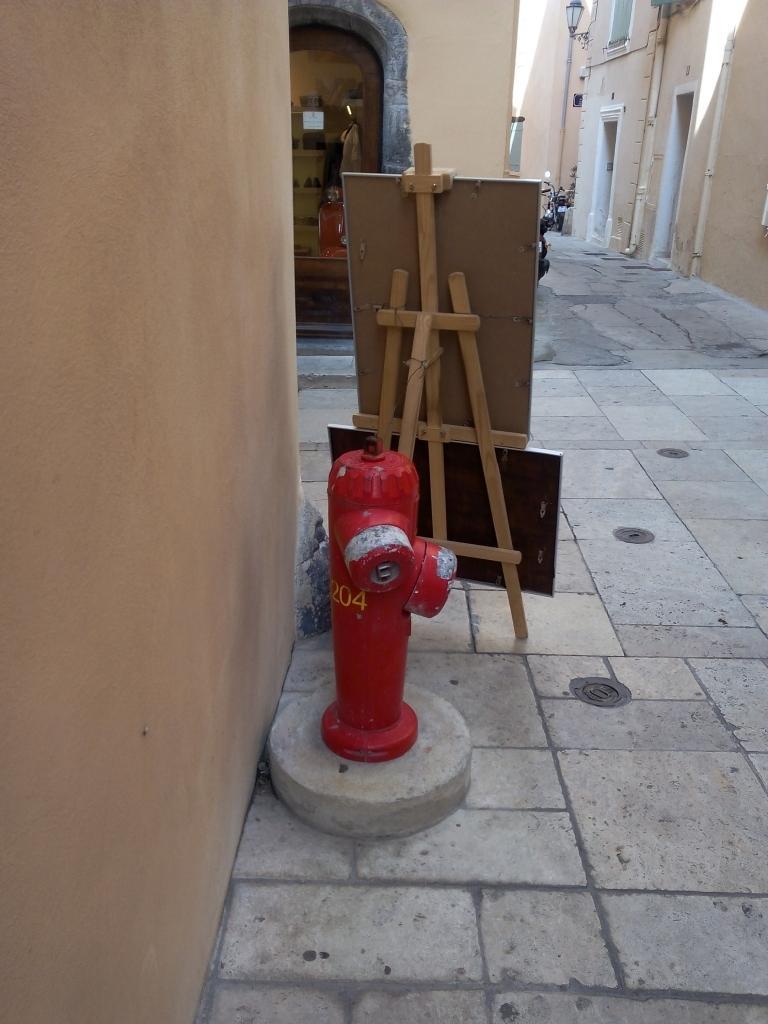Please provide a concise description of this image. This picture consists of outside view of a city and I can see a building , in front of the building I can see a fire extinguisher and boards kept on the floor and I can see a wall in the left side. 